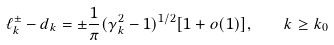<formula> <loc_0><loc_0><loc_500><loc_500>\ell _ { k } ^ { \pm } - d _ { k } = \pm \frac { 1 } { \pi } ( \gamma _ { k } ^ { 2 } - 1 ) ^ { 1 / 2 } [ 1 + o ( 1 ) ] , \quad k \geq k _ { 0 }</formula> 